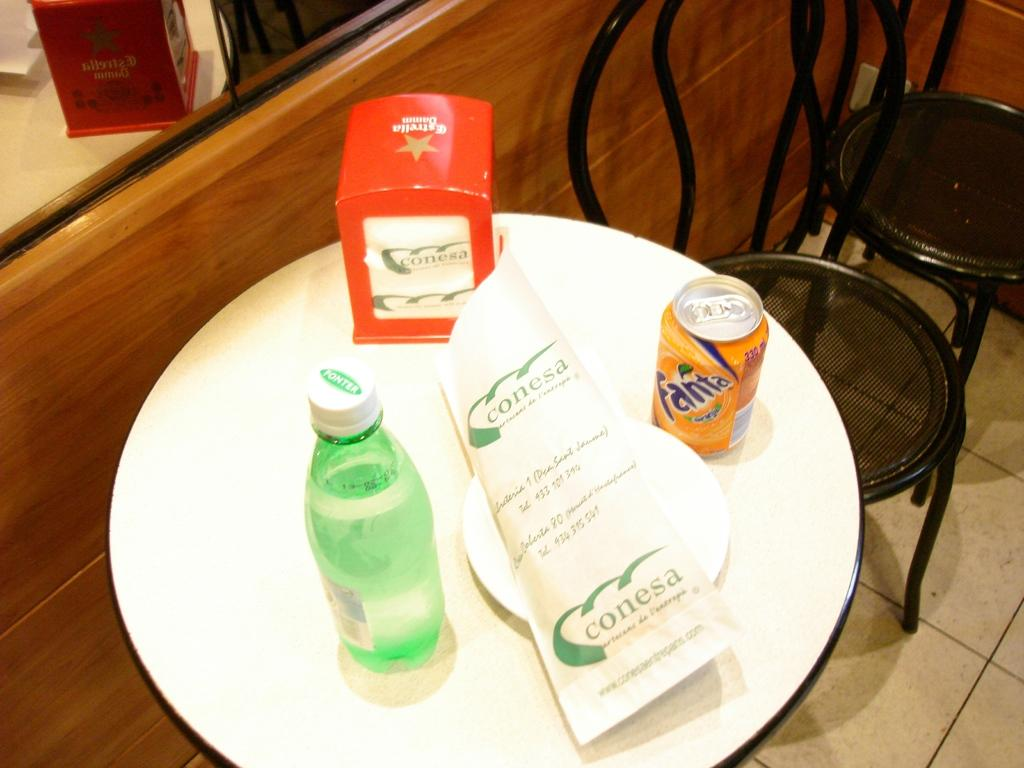<image>
Offer a succinct explanation of the picture presented. A small round table with a can of orange Fanta at a place called Conesa. 